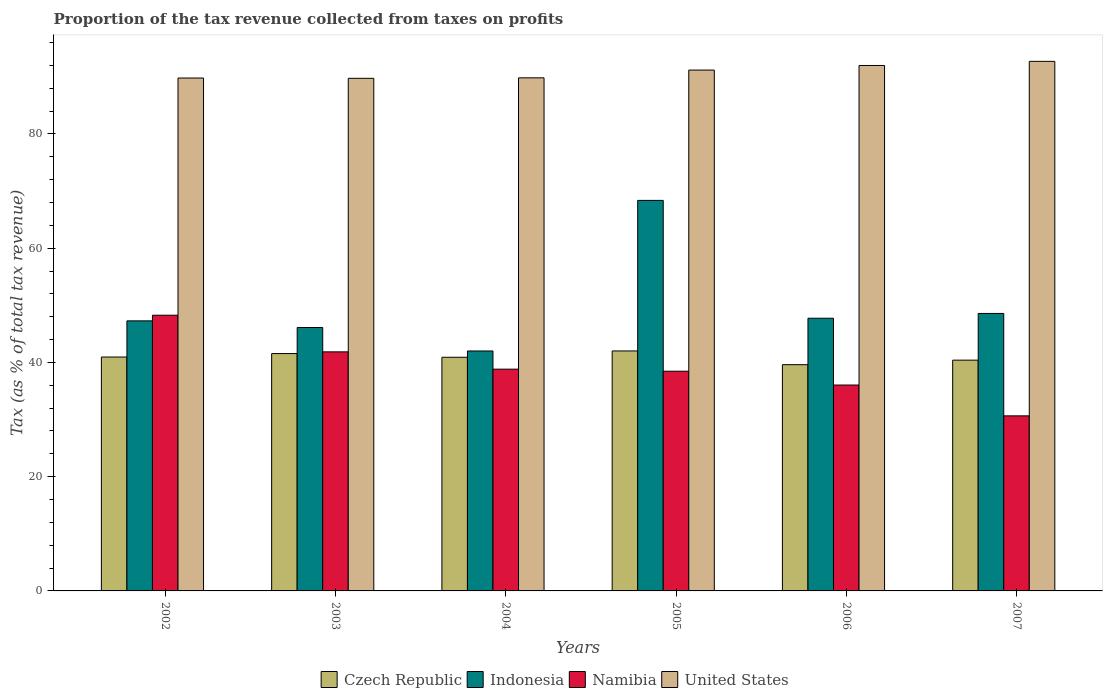How many different coloured bars are there?
Provide a succinct answer. 4. How many groups of bars are there?
Provide a short and direct response. 6. Are the number of bars per tick equal to the number of legend labels?
Your answer should be compact. Yes. Are the number of bars on each tick of the X-axis equal?
Your response must be concise. Yes. How many bars are there on the 2nd tick from the left?
Provide a short and direct response. 4. What is the label of the 2nd group of bars from the left?
Provide a succinct answer. 2003. In how many cases, is the number of bars for a given year not equal to the number of legend labels?
Give a very brief answer. 0. What is the proportion of the tax revenue collected in Indonesia in 2005?
Your answer should be compact. 68.37. Across all years, what is the maximum proportion of the tax revenue collected in Indonesia?
Provide a short and direct response. 68.37. Across all years, what is the minimum proportion of the tax revenue collected in Czech Republic?
Offer a terse response. 39.61. In which year was the proportion of the tax revenue collected in Czech Republic maximum?
Your response must be concise. 2005. What is the total proportion of the tax revenue collected in United States in the graph?
Make the answer very short. 545.26. What is the difference between the proportion of the tax revenue collected in Namibia in 2003 and that in 2005?
Give a very brief answer. 3.39. What is the difference between the proportion of the tax revenue collected in United States in 2006 and the proportion of the tax revenue collected in Namibia in 2004?
Keep it short and to the point. 53.17. What is the average proportion of the tax revenue collected in Namibia per year?
Your answer should be compact. 39.02. In the year 2005, what is the difference between the proportion of the tax revenue collected in Czech Republic and proportion of the tax revenue collected in United States?
Give a very brief answer. -49.17. What is the ratio of the proportion of the tax revenue collected in United States in 2003 to that in 2005?
Provide a short and direct response. 0.98. Is the proportion of the tax revenue collected in Indonesia in 2003 less than that in 2007?
Provide a succinct answer. Yes. What is the difference between the highest and the second highest proportion of the tax revenue collected in United States?
Offer a terse response. 0.72. What is the difference between the highest and the lowest proportion of the tax revenue collected in Czech Republic?
Provide a short and direct response. 2.4. In how many years, is the proportion of the tax revenue collected in Czech Republic greater than the average proportion of the tax revenue collected in Czech Republic taken over all years?
Your response must be concise. 3. Is the sum of the proportion of the tax revenue collected in Czech Republic in 2003 and 2007 greater than the maximum proportion of the tax revenue collected in Namibia across all years?
Your response must be concise. Yes. What does the 1st bar from the left in 2007 represents?
Keep it short and to the point. Czech Republic. What does the 2nd bar from the right in 2006 represents?
Make the answer very short. Namibia. How many bars are there?
Offer a very short reply. 24. What is the difference between two consecutive major ticks on the Y-axis?
Make the answer very short. 20. Are the values on the major ticks of Y-axis written in scientific E-notation?
Make the answer very short. No. How are the legend labels stacked?
Provide a short and direct response. Horizontal. What is the title of the graph?
Ensure brevity in your answer.  Proportion of the tax revenue collected from taxes on profits. What is the label or title of the Y-axis?
Your response must be concise. Tax (as % of total tax revenue). What is the Tax (as % of total tax revenue) of Czech Republic in 2002?
Offer a very short reply. 40.95. What is the Tax (as % of total tax revenue) in Indonesia in 2002?
Give a very brief answer. 47.28. What is the Tax (as % of total tax revenue) of Namibia in 2002?
Offer a very short reply. 48.27. What is the Tax (as % of total tax revenue) in United States in 2002?
Your answer should be very brief. 89.8. What is the Tax (as % of total tax revenue) in Czech Republic in 2003?
Your response must be concise. 41.55. What is the Tax (as % of total tax revenue) of Indonesia in 2003?
Your answer should be very brief. 46.12. What is the Tax (as % of total tax revenue) in Namibia in 2003?
Your answer should be compact. 41.85. What is the Tax (as % of total tax revenue) of United States in 2003?
Your answer should be compact. 89.74. What is the Tax (as % of total tax revenue) of Czech Republic in 2004?
Keep it short and to the point. 40.91. What is the Tax (as % of total tax revenue) in Indonesia in 2004?
Your answer should be compact. 42.01. What is the Tax (as % of total tax revenue) in Namibia in 2004?
Your answer should be compact. 38.82. What is the Tax (as % of total tax revenue) of United States in 2004?
Give a very brief answer. 89.83. What is the Tax (as % of total tax revenue) in Czech Republic in 2005?
Your response must be concise. 42.01. What is the Tax (as % of total tax revenue) in Indonesia in 2005?
Make the answer very short. 68.37. What is the Tax (as % of total tax revenue) of Namibia in 2005?
Make the answer very short. 38.47. What is the Tax (as % of total tax revenue) in United States in 2005?
Provide a short and direct response. 91.19. What is the Tax (as % of total tax revenue) in Czech Republic in 2006?
Provide a short and direct response. 39.61. What is the Tax (as % of total tax revenue) in Indonesia in 2006?
Your response must be concise. 47.74. What is the Tax (as % of total tax revenue) in Namibia in 2006?
Your answer should be very brief. 36.05. What is the Tax (as % of total tax revenue) in United States in 2006?
Ensure brevity in your answer.  91.99. What is the Tax (as % of total tax revenue) in Czech Republic in 2007?
Offer a terse response. 40.4. What is the Tax (as % of total tax revenue) in Indonesia in 2007?
Keep it short and to the point. 48.58. What is the Tax (as % of total tax revenue) in Namibia in 2007?
Your response must be concise. 30.65. What is the Tax (as % of total tax revenue) of United States in 2007?
Your answer should be very brief. 92.71. Across all years, what is the maximum Tax (as % of total tax revenue) in Czech Republic?
Your response must be concise. 42.01. Across all years, what is the maximum Tax (as % of total tax revenue) in Indonesia?
Your answer should be very brief. 68.37. Across all years, what is the maximum Tax (as % of total tax revenue) of Namibia?
Provide a short and direct response. 48.27. Across all years, what is the maximum Tax (as % of total tax revenue) in United States?
Offer a terse response. 92.71. Across all years, what is the minimum Tax (as % of total tax revenue) in Czech Republic?
Your answer should be very brief. 39.61. Across all years, what is the minimum Tax (as % of total tax revenue) in Indonesia?
Provide a succinct answer. 42.01. Across all years, what is the minimum Tax (as % of total tax revenue) in Namibia?
Give a very brief answer. 30.65. Across all years, what is the minimum Tax (as % of total tax revenue) of United States?
Ensure brevity in your answer.  89.74. What is the total Tax (as % of total tax revenue) in Czech Republic in the graph?
Provide a short and direct response. 245.44. What is the total Tax (as % of total tax revenue) in Indonesia in the graph?
Your answer should be compact. 300.09. What is the total Tax (as % of total tax revenue) of Namibia in the graph?
Make the answer very short. 234.11. What is the total Tax (as % of total tax revenue) in United States in the graph?
Provide a succinct answer. 545.26. What is the difference between the Tax (as % of total tax revenue) in Czech Republic in 2002 and that in 2003?
Offer a terse response. -0.6. What is the difference between the Tax (as % of total tax revenue) of Indonesia in 2002 and that in 2003?
Your response must be concise. 1.16. What is the difference between the Tax (as % of total tax revenue) in Namibia in 2002 and that in 2003?
Ensure brevity in your answer.  6.42. What is the difference between the Tax (as % of total tax revenue) in United States in 2002 and that in 2003?
Keep it short and to the point. 0.05. What is the difference between the Tax (as % of total tax revenue) of Czech Republic in 2002 and that in 2004?
Your response must be concise. 0.04. What is the difference between the Tax (as % of total tax revenue) of Indonesia in 2002 and that in 2004?
Give a very brief answer. 5.27. What is the difference between the Tax (as % of total tax revenue) of Namibia in 2002 and that in 2004?
Provide a succinct answer. 9.45. What is the difference between the Tax (as % of total tax revenue) of United States in 2002 and that in 2004?
Offer a terse response. -0.03. What is the difference between the Tax (as % of total tax revenue) of Czech Republic in 2002 and that in 2005?
Offer a very short reply. -1.06. What is the difference between the Tax (as % of total tax revenue) of Indonesia in 2002 and that in 2005?
Make the answer very short. -21.09. What is the difference between the Tax (as % of total tax revenue) of Namibia in 2002 and that in 2005?
Offer a very short reply. 9.8. What is the difference between the Tax (as % of total tax revenue) in United States in 2002 and that in 2005?
Make the answer very short. -1.39. What is the difference between the Tax (as % of total tax revenue) in Czech Republic in 2002 and that in 2006?
Offer a terse response. 1.34. What is the difference between the Tax (as % of total tax revenue) of Indonesia in 2002 and that in 2006?
Provide a succinct answer. -0.46. What is the difference between the Tax (as % of total tax revenue) in Namibia in 2002 and that in 2006?
Make the answer very short. 12.22. What is the difference between the Tax (as % of total tax revenue) in United States in 2002 and that in 2006?
Keep it short and to the point. -2.2. What is the difference between the Tax (as % of total tax revenue) of Czech Republic in 2002 and that in 2007?
Ensure brevity in your answer.  0.55. What is the difference between the Tax (as % of total tax revenue) of Indonesia in 2002 and that in 2007?
Give a very brief answer. -1.3. What is the difference between the Tax (as % of total tax revenue) in Namibia in 2002 and that in 2007?
Keep it short and to the point. 17.62. What is the difference between the Tax (as % of total tax revenue) in United States in 2002 and that in 2007?
Your response must be concise. -2.92. What is the difference between the Tax (as % of total tax revenue) of Czech Republic in 2003 and that in 2004?
Offer a terse response. 0.65. What is the difference between the Tax (as % of total tax revenue) of Indonesia in 2003 and that in 2004?
Give a very brief answer. 4.11. What is the difference between the Tax (as % of total tax revenue) of Namibia in 2003 and that in 2004?
Keep it short and to the point. 3.03. What is the difference between the Tax (as % of total tax revenue) in United States in 2003 and that in 2004?
Make the answer very short. -0.08. What is the difference between the Tax (as % of total tax revenue) in Czech Republic in 2003 and that in 2005?
Your answer should be very brief. -0.46. What is the difference between the Tax (as % of total tax revenue) of Indonesia in 2003 and that in 2005?
Your answer should be very brief. -22.25. What is the difference between the Tax (as % of total tax revenue) in Namibia in 2003 and that in 2005?
Offer a very short reply. 3.39. What is the difference between the Tax (as % of total tax revenue) in United States in 2003 and that in 2005?
Ensure brevity in your answer.  -1.44. What is the difference between the Tax (as % of total tax revenue) of Czech Republic in 2003 and that in 2006?
Give a very brief answer. 1.95. What is the difference between the Tax (as % of total tax revenue) of Indonesia in 2003 and that in 2006?
Your response must be concise. -1.62. What is the difference between the Tax (as % of total tax revenue) of Namibia in 2003 and that in 2006?
Your answer should be compact. 5.81. What is the difference between the Tax (as % of total tax revenue) of United States in 2003 and that in 2006?
Offer a terse response. -2.25. What is the difference between the Tax (as % of total tax revenue) in Czech Republic in 2003 and that in 2007?
Ensure brevity in your answer.  1.15. What is the difference between the Tax (as % of total tax revenue) in Indonesia in 2003 and that in 2007?
Ensure brevity in your answer.  -2.46. What is the difference between the Tax (as % of total tax revenue) of Namibia in 2003 and that in 2007?
Your answer should be very brief. 11.2. What is the difference between the Tax (as % of total tax revenue) of United States in 2003 and that in 2007?
Offer a terse response. -2.97. What is the difference between the Tax (as % of total tax revenue) of Czech Republic in 2004 and that in 2005?
Provide a succinct answer. -1.11. What is the difference between the Tax (as % of total tax revenue) of Indonesia in 2004 and that in 2005?
Provide a succinct answer. -26.36. What is the difference between the Tax (as % of total tax revenue) in Namibia in 2004 and that in 2005?
Your answer should be compact. 0.36. What is the difference between the Tax (as % of total tax revenue) in United States in 2004 and that in 2005?
Provide a succinct answer. -1.36. What is the difference between the Tax (as % of total tax revenue) in Czech Republic in 2004 and that in 2006?
Offer a very short reply. 1.3. What is the difference between the Tax (as % of total tax revenue) of Indonesia in 2004 and that in 2006?
Keep it short and to the point. -5.73. What is the difference between the Tax (as % of total tax revenue) in Namibia in 2004 and that in 2006?
Ensure brevity in your answer.  2.78. What is the difference between the Tax (as % of total tax revenue) of United States in 2004 and that in 2006?
Ensure brevity in your answer.  -2.17. What is the difference between the Tax (as % of total tax revenue) in Czech Republic in 2004 and that in 2007?
Offer a terse response. 0.5. What is the difference between the Tax (as % of total tax revenue) in Indonesia in 2004 and that in 2007?
Give a very brief answer. -6.57. What is the difference between the Tax (as % of total tax revenue) of Namibia in 2004 and that in 2007?
Ensure brevity in your answer.  8.17. What is the difference between the Tax (as % of total tax revenue) of United States in 2004 and that in 2007?
Keep it short and to the point. -2.89. What is the difference between the Tax (as % of total tax revenue) of Czech Republic in 2005 and that in 2006?
Provide a short and direct response. 2.4. What is the difference between the Tax (as % of total tax revenue) in Indonesia in 2005 and that in 2006?
Ensure brevity in your answer.  20.63. What is the difference between the Tax (as % of total tax revenue) of Namibia in 2005 and that in 2006?
Offer a terse response. 2.42. What is the difference between the Tax (as % of total tax revenue) in United States in 2005 and that in 2006?
Make the answer very short. -0.81. What is the difference between the Tax (as % of total tax revenue) in Czech Republic in 2005 and that in 2007?
Your response must be concise. 1.61. What is the difference between the Tax (as % of total tax revenue) of Indonesia in 2005 and that in 2007?
Provide a succinct answer. 19.79. What is the difference between the Tax (as % of total tax revenue) in Namibia in 2005 and that in 2007?
Provide a succinct answer. 7.82. What is the difference between the Tax (as % of total tax revenue) of United States in 2005 and that in 2007?
Keep it short and to the point. -1.53. What is the difference between the Tax (as % of total tax revenue) in Czech Republic in 2006 and that in 2007?
Provide a short and direct response. -0.79. What is the difference between the Tax (as % of total tax revenue) of Indonesia in 2006 and that in 2007?
Make the answer very short. -0.84. What is the difference between the Tax (as % of total tax revenue) in Namibia in 2006 and that in 2007?
Give a very brief answer. 5.4. What is the difference between the Tax (as % of total tax revenue) of United States in 2006 and that in 2007?
Provide a short and direct response. -0.72. What is the difference between the Tax (as % of total tax revenue) in Czech Republic in 2002 and the Tax (as % of total tax revenue) in Indonesia in 2003?
Your answer should be very brief. -5.17. What is the difference between the Tax (as % of total tax revenue) of Czech Republic in 2002 and the Tax (as % of total tax revenue) of Namibia in 2003?
Provide a short and direct response. -0.9. What is the difference between the Tax (as % of total tax revenue) in Czech Republic in 2002 and the Tax (as % of total tax revenue) in United States in 2003?
Provide a succinct answer. -48.79. What is the difference between the Tax (as % of total tax revenue) of Indonesia in 2002 and the Tax (as % of total tax revenue) of Namibia in 2003?
Give a very brief answer. 5.43. What is the difference between the Tax (as % of total tax revenue) in Indonesia in 2002 and the Tax (as % of total tax revenue) in United States in 2003?
Keep it short and to the point. -42.46. What is the difference between the Tax (as % of total tax revenue) in Namibia in 2002 and the Tax (as % of total tax revenue) in United States in 2003?
Offer a terse response. -41.47. What is the difference between the Tax (as % of total tax revenue) in Czech Republic in 2002 and the Tax (as % of total tax revenue) in Indonesia in 2004?
Provide a succinct answer. -1.06. What is the difference between the Tax (as % of total tax revenue) in Czech Republic in 2002 and the Tax (as % of total tax revenue) in Namibia in 2004?
Offer a terse response. 2.13. What is the difference between the Tax (as % of total tax revenue) of Czech Republic in 2002 and the Tax (as % of total tax revenue) of United States in 2004?
Give a very brief answer. -48.88. What is the difference between the Tax (as % of total tax revenue) of Indonesia in 2002 and the Tax (as % of total tax revenue) of Namibia in 2004?
Offer a terse response. 8.46. What is the difference between the Tax (as % of total tax revenue) of Indonesia in 2002 and the Tax (as % of total tax revenue) of United States in 2004?
Provide a succinct answer. -42.55. What is the difference between the Tax (as % of total tax revenue) in Namibia in 2002 and the Tax (as % of total tax revenue) in United States in 2004?
Your response must be concise. -41.56. What is the difference between the Tax (as % of total tax revenue) in Czech Republic in 2002 and the Tax (as % of total tax revenue) in Indonesia in 2005?
Provide a short and direct response. -27.42. What is the difference between the Tax (as % of total tax revenue) in Czech Republic in 2002 and the Tax (as % of total tax revenue) in Namibia in 2005?
Your answer should be very brief. 2.48. What is the difference between the Tax (as % of total tax revenue) in Czech Republic in 2002 and the Tax (as % of total tax revenue) in United States in 2005?
Keep it short and to the point. -50.24. What is the difference between the Tax (as % of total tax revenue) in Indonesia in 2002 and the Tax (as % of total tax revenue) in Namibia in 2005?
Your answer should be compact. 8.81. What is the difference between the Tax (as % of total tax revenue) of Indonesia in 2002 and the Tax (as % of total tax revenue) of United States in 2005?
Your answer should be very brief. -43.91. What is the difference between the Tax (as % of total tax revenue) in Namibia in 2002 and the Tax (as % of total tax revenue) in United States in 2005?
Give a very brief answer. -42.92. What is the difference between the Tax (as % of total tax revenue) in Czech Republic in 2002 and the Tax (as % of total tax revenue) in Indonesia in 2006?
Give a very brief answer. -6.79. What is the difference between the Tax (as % of total tax revenue) of Czech Republic in 2002 and the Tax (as % of total tax revenue) of Namibia in 2006?
Ensure brevity in your answer.  4.9. What is the difference between the Tax (as % of total tax revenue) in Czech Republic in 2002 and the Tax (as % of total tax revenue) in United States in 2006?
Provide a short and direct response. -51.04. What is the difference between the Tax (as % of total tax revenue) in Indonesia in 2002 and the Tax (as % of total tax revenue) in Namibia in 2006?
Keep it short and to the point. 11.23. What is the difference between the Tax (as % of total tax revenue) of Indonesia in 2002 and the Tax (as % of total tax revenue) of United States in 2006?
Make the answer very short. -44.71. What is the difference between the Tax (as % of total tax revenue) in Namibia in 2002 and the Tax (as % of total tax revenue) in United States in 2006?
Provide a succinct answer. -43.72. What is the difference between the Tax (as % of total tax revenue) in Czech Republic in 2002 and the Tax (as % of total tax revenue) in Indonesia in 2007?
Your response must be concise. -7.63. What is the difference between the Tax (as % of total tax revenue) of Czech Republic in 2002 and the Tax (as % of total tax revenue) of Namibia in 2007?
Offer a very short reply. 10.3. What is the difference between the Tax (as % of total tax revenue) in Czech Republic in 2002 and the Tax (as % of total tax revenue) in United States in 2007?
Keep it short and to the point. -51.76. What is the difference between the Tax (as % of total tax revenue) of Indonesia in 2002 and the Tax (as % of total tax revenue) of Namibia in 2007?
Your answer should be compact. 16.63. What is the difference between the Tax (as % of total tax revenue) of Indonesia in 2002 and the Tax (as % of total tax revenue) of United States in 2007?
Ensure brevity in your answer.  -45.43. What is the difference between the Tax (as % of total tax revenue) of Namibia in 2002 and the Tax (as % of total tax revenue) of United States in 2007?
Ensure brevity in your answer.  -44.45. What is the difference between the Tax (as % of total tax revenue) of Czech Republic in 2003 and the Tax (as % of total tax revenue) of Indonesia in 2004?
Offer a very short reply. -0.45. What is the difference between the Tax (as % of total tax revenue) in Czech Republic in 2003 and the Tax (as % of total tax revenue) in Namibia in 2004?
Provide a short and direct response. 2.73. What is the difference between the Tax (as % of total tax revenue) in Czech Republic in 2003 and the Tax (as % of total tax revenue) in United States in 2004?
Provide a short and direct response. -48.27. What is the difference between the Tax (as % of total tax revenue) in Indonesia in 2003 and the Tax (as % of total tax revenue) in Namibia in 2004?
Your answer should be very brief. 7.29. What is the difference between the Tax (as % of total tax revenue) of Indonesia in 2003 and the Tax (as % of total tax revenue) of United States in 2004?
Provide a succinct answer. -43.71. What is the difference between the Tax (as % of total tax revenue) in Namibia in 2003 and the Tax (as % of total tax revenue) in United States in 2004?
Offer a very short reply. -47.97. What is the difference between the Tax (as % of total tax revenue) in Czech Republic in 2003 and the Tax (as % of total tax revenue) in Indonesia in 2005?
Keep it short and to the point. -26.82. What is the difference between the Tax (as % of total tax revenue) in Czech Republic in 2003 and the Tax (as % of total tax revenue) in Namibia in 2005?
Your answer should be compact. 3.09. What is the difference between the Tax (as % of total tax revenue) of Czech Republic in 2003 and the Tax (as % of total tax revenue) of United States in 2005?
Your answer should be compact. -49.63. What is the difference between the Tax (as % of total tax revenue) of Indonesia in 2003 and the Tax (as % of total tax revenue) of Namibia in 2005?
Ensure brevity in your answer.  7.65. What is the difference between the Tax (as % of total tax revenue) of Indonesia in 2003 and the Tax (as % of total tax revenue) of United States in 2005?
Provide a short and direct response. -45.07. What is the difference between the Tax (as % of total tax revenue) of Namibia in 2003 and the Tax (as % of total tax revenue) of United States in 2005?
Give a very brief answer. -49.33. What is the difference between the Tax (as % of total tax revenue) of Czech Republic in 2003 and the Tax (as % of total tax revenue) of Indonesia in 2006?
Give a very brief answer. -6.18. What is the difference between the Tax (as % of total tax revenue) of Czech Republic in 2003 and the Tax (as % of total tax revenue) of Namibia in 2006?
Give a very brief answer. 5.51. What is the difference between the Tax (as % of total tax revenue) in Czech Republic in 2003 and the Tax (as % of total tax revenue) in United States in 2006?
Make the answer very short. -50.44. What is the difference between the Tax (as % of total tax revenue) of Indonesia in 2003 and the Tax (as % of total tax revenue) of Namibia in 2006?
Keep it short and to the point. 10.07. What is the difference between the Tax (as % of total tax revenue) of Indonesia in 2003 and the Tax (as % of total tax revenue) of United States in 2006?
Give a very brief answer. -45.88. What is the difference between the Tax (as % of total tax revenue) in Namibia in 2003 and the Tax (as % of total tax revenue) in United States in 2006?
Your answer should be very brief. -50.14. What is the difference between the Tax (as % of total tax revenue) of Czech Republic in 2003 and the Tax (as % of total tax revenue) of Indonesia in 2007?
Your answer should be very brief. -7.02. What is the difference between the Tax (as % of total tax revenue) in Czech Republic in 2003 and the Tax (as % of total tax revenue) in Namibia in 2007?
Ensure brevity in your answer.  10.9. What is the difference between the Tax (as % of total tax revenue) in Czech Republic in 2003 and the Tax (as % of total tax revenue) in United States in 2007?
Your response must be concise. -51.16. What is the difference between the Tax (as % of total tax revenue) in Indonesia in 2003 and the Tax (as % of total tax revenue) in Namibia in 2007?
Your answer should be very brief. 15.47. What is the difference between the Tax (as % of total tax revenue) of Indonesia in 2003 and the Tax (as % of total tax revenue) of United States in 2007?
Offer a terse response. -46.6. What is the difference between the Tax (as % of total tax revenue) of Namibia in 2003 and the Tax (as % of total tax revenue) of United States in 2007?
Make the answer very short. -50.86. What is the difference between the Tax (as % of total tax revenue) in Czech Republic in 2004 and the Tax (as % of total tax revenue) in Indonesia in 2005?
Offer a terse response. -27.46. What is the difference between the Tax (as % of total tax revenue) of Czech Republic in 2004 and the Tax (as % of total tax revenue) of Namibia in 2005?
Keep it short and to the point. 2.44. What is the difference between the Tax (as % of total tax revenue) in Czech Republic in 2004 and the Tax (as % of total tax revenue) in United States in 2005?
Offer a terse response. -50.28. What is the difference between the Tax (as % of total tax revenue) of Indonesia in 2004 and the Tax (as % of total tax revenue) of Namibia in 2005?
Offer a terse response. 3.54. What is the difference between the Tax (as % of total tax revenue) in Indonesia in 2004 and the Tax (as % of total tax revenue) in United States in 2005?
Keep it short and to the point. -49.18. What is the difference between the Tax (as % of total tax revenue) in Namibia in 2004 and the Tax (as % of total tax revenue) in United States in 2005?
Provide a short and direct response. -52.36. What is the difference between the Tax (as % of total tax revenue) of Czech Republic in 2004 and the Tax (as % of total tax revenue) of Indonesia in 2006?
Offer a terse response. -6.83. What is the difference between the Tax (as % of total tax revenue) of Czech Republic in 2004 and the Tax (as % of total tax revenue) of Namibia in 2006?
Your answer should be compact. 4.86. What is the difference between the Tax (as % of total tax revenue) in Czech Republic in 2004 and the Tax (as % of total tax revenue) in United States in 2006?
Your response must be concise. -51.09. What is the difference between the Tax (as % of total tax revenue) in Indonesia in 2004 and the Tax (as % of total tax revenue) in Namibia in 2006?
Your answer should be compact. 5.96. What is the difference between the Tax (as % of total tax revenue) in Indonesia in 2004 and the Tax (as % of total tax revenue) in United States in 2006?
Provide a short and direct response. -49.99. What is the difference between the Tax (as % of total tax revenue) of Namibia in 2004 and the Tax (as % of total tax revenue) of United States in 2006?
Offer a very short reply. -53.17. What is the difference between the Tax (as % of total tax revenue) of Czech Republic in 2004 and the Tax (as % of total tax revenue) of Indonesia in 2007?
Your answer should be compact. -7.67. What is the difference between the Tax (as % of total tax revenue) in Czech Republic in 2004 and the Tax (as % of total tax revenue) in Namibia in 2007?
Your response must be concise. 10.26. What is the difference between the Tax (as % of total tax revenue) of Czech Republic in 2004 and the Tax (as % of total tax revenue) of United States in 2007?
Your answer should be compact. -51.81. What is the difference between the Tax (as % of total tax revenue) of Indonesia in 2004 and the Tax (as % of total tax revenue) of Namibia in 2007?
Ensure brevity in your answer.  11.36. What is the difference between the Tax (as % of total tax revenue) in Indonesia in 2004 and the Tax (as % of total tax revenue) in United States in 2007?
Your answer should be compact. -50.71. What is the difference between the Tax (as % of total tax revenue) of Namibia in 2004 and the Tax (as % of total tax revenue) of United States in 2007?
Keep it short and to the point. -53.89. What is the difference between the Tax (as % of total tax revenue) in Czech Republic in 2005 and the Tax (as % of total tax revenue) in Indonesia in 2006?
Your answer should be very brief. -5.73. What is the difference between the Tax (as % of total tax revenue) in Czech Republic in 2005 and the Tax (as % of total tax revenue) in Namibia in 2006?
Offer a terse response. 5.97. What is the difference between the Tax (as % of total tax revenue) of Czech Republic in 2005 and the Tax (as % of total tax revenue) of United States in 2006?
Provide a succinct answer. -49.98. What is the difference between the Tax (as % of total tax revenue) in Indonesia in 2005 and the Tax (as % of total tax revenue) in Namibia in 2006?
Your answer should be compact. 32.32. What is the difference between the Tax (as % of total tax revenue) in Indonesia in 2005 and the Tax (as % of total tax revenue) in United States in 2006?
Provide a succinct answer. -23.62. What is the difference between the Tax (as % of total tax revenue) in Namibia in 2005 and the Tax (as % of total tax revenue) in United States in 2006?
Your answer should be very brief. -53.53. What is the difference between the Tax (as % of total tax revenue) in Czech Republic in 2005 and the Tax (as % of total tax revenue) in Indonesia in 2007?
Offer a very short reply. -6.57. What is the difference between the Tax (as % of total tax revenue) of Czech Republic in 2005 and the Tax (as % of total tax revenue) of Namibia in 2007?
Provide a succinct answer. 11.36. What is the difference between the Tax (as % of total tax revenue) of Czech Republic in 2005 and the Tax (as % of total tax revenue) of United States in 2007?
Offer a terse response. -50.7. What is the difference between the Tax (as % of total tax revenue) in Indonesia in 2005 and the Tax (as % of total tax revenue) in Namibia in 2007?
Give a very brief answer. 37.72. What is the difference between the Tax (as % of total tax revenue) of Indonesia in 2005 and the Tax (as % of total tax revenue) of United States in 2007?
Provide a succinct answer. -24.34. What is the difference between the Tax (as % of total tax revenue) of Namibia in 2005 and the Tax (as % of total tax revenue) of United States in 2007?
Provide a short and direct response. -54.25. What is the difference between the Tax (as % of total tax revenue) in Czech Republic in 2006 and the Tax (as % of total tax revenue) in Indonesia in 2007?
Make the answer very short. -8.97. What is the difference between the Tax (as % of total tax revenue) in Czech Republic in 2006 and the Tax (as % of total tax revenue) in Namibia in 2007?
Provide a succinct answer. 8.96. What is the difference between the Tax (as % of total tax revenue) of Czech Republic in 2006 and the Tax (as % of total tax revenue) of United States in 2007?
Offer a very short reply. -53.11. What is the difference between the Tax (as % of total tax revenue) in Indonesia in 2006 and the Tax (as % of total tax revenue) in Namibia in 2007?
Offer a terse response. 17.09. What is the difference between the Tax (as % of total tax revenue) in Indonesia in 2006 and the Tax (as % of total tax revenue) in United States in 2007?
Keep it short and to the point. -44.98. What is the difference between the Tax (as % of total tax revenue) of Namibia in 2006 and the Tax (as % of total tax revenue) of United States in 2007?
Your answer should be compact. -56.67. What is the average Tax (as % of total tax revenue) in Czech Republic per year?
Your response must be concise. 40.91. What is the average Tax (as % of total tax revenue) of Indonesia per year?
Provide a succinct answer. 50.02. What is the average Tax (as % of total tax revenue) in Namibia per year?
Your response must be concise. 39.02. What is the average Tax (as % of total tax revenue) in United States per year?
Make the answer very short. 90.88. In the year 2002, what is the difference between the Tax (as % of total tax revenue) of Czech Republic and Tax (as % of total tax revenue) of Indonesia?
Make the answer very short. -6.33. In the year 2002, what is the difference between the Tax (as % of total tax revenue) of Czech Republic and Tax (as % of total tax revenue) of Namibia?
Give a very brief answer. -7.32. In the year 2002, what is the difference between the Tax (as % of total tax revenue) in Czech Republic and Tax (as % of total tax revenue) in United States?
Ensure brevity in your answer.  -48.85. In the year 2002, what is the difference between the Tax (as % of total tax revenue) in Indonesia and Tax (as % of total tax revenue) in Namibia?
Your response must be concise. -0.99. In the year 2002, what is the difference between the Tax (as % of total tax revenue) of Indonesia and Tax (as % of total tax revenue) of United States?
Provide a succinct answer. -42.52. In the year 2002, what is the difference between the Tax (as % of total tax revenue) in Namibia and Tax (as % of total tax revenue) in United States?
Provide a short and direct response. -41.53. In the year 2003, what is the difference between the Tax (as % of total tax revenue) of Czech Republic and Tax (as % of total tax revenue) of Indonesia?
Provide a succinct answer. -4.56. In the year 2003, what is the difference between the Tax (as % of total tax revenue) in Czech Republic and Tax (as % of total tax revenue) in Namibia?
Keep it short and to the point. -0.3. In the year 2003, what is the difference between the Tax (as % of total tax revenue) in Czech Republic and Tax (as % of total tax revenue) in United States?
Give a very brief answer. -48.19. In the year 2003, what is the difference between the Tax (as % of total tax revenue) in Indonesia and Tax (as % of total tax revenue) in Namibia?
Your answer should be very brief. 4.26. In the year 2003, what is the difference between the Tax (as % of total tax revenue) of Indonesia and Tax (as % of total tax revenue) of United States?
Your response must be concise. -43.63. In the year 2003, what is the difference between the Tax (as % of total tax revenue) in Namibia and Tax (as % of total tax revenue) in United States?
Offer a terse response. -47.89. In the year 2004, what is the difference between the Tax (as % of total tax revenue) of Czech Republic and Tax (as % of total tax revenue) of Indonesia?
Provide a succinct answer. -1.1. In the year 2004, what is the difference between the Tax (as % of total tax revenue) in Czech Republic and Tax (as % of total tax revenue) in Namibia?
Offer a very short reply. 2.08. In the year 2004, what is the difference between the Tax (as % of total tax revenue) in Czech Republic and Tax (as % of total tax revenue) in United States?
Ensure brevity in your answer.  -48.92. In the year 2004, what is the difference between the Tax (as % of total tax revenue) in Indonesia and Tax (as % of total tax revenue) in Namibia?
Your answer should be very brief. 3.18. In the year 2004, what is the difference between the Tax (as % of total tax revenue) of Indonesia and Tax (as % of total tax revenue) of United States?
Give a very brief answer. -47.82. In the year 2004, what is the difference between the Tax (as % of total tax revenue) in Namibia and Tax (as % of total tax revenue) in United States?
Offer a very short reply. -51. In the year 2005, what is the difference between the Tax (as % of total tax revenue) in Czech Republic and Tax (as % of total tax revenue) in Indonesia?
Provide a succinct answer. -26.36. In the year 2005, what is the difference between the Tax (as % of total tax revenue) of Czech Republic and Tax (as % of total tax revenue) of Namibia?
Provide a short and direct response. 3.55. In the year 2005, what is the difference between the Tax (as % of total tax revenue) of Czech Republic and Tax (as % of total tax revenue) of United States?
Your answer should be compact. -49.17. In the year 2005, what is the difference between the Tax (as % of total tax revenue) in Indonesia and Tax (as % of total tax revenue) in Namibia?
Your answer should be very brief. 29.9. In the year 2005, what is the difference between the Tax (as % of total tax revenue) of Indonesia and Tax (as % of total tax revenue) of United States?
Keep it short and to the point. -22.82. In the year 2005, what is the difference between the Tax (as % of total tax revenue) in Namibia and Tax (as % of total tax revenue) in United States?
Your response must be concise. -52.72. In the year 2006, what is the difference between the Tax (as % of total tax revenue) of Czech Republic and Tax (as % of total tax revenue) of Indonesia?
Your answer should be compact. -8.13. In the year 2006, what is the difference between the Tax (as % of total tax revenue) of Czech Republic and Tax (as % of total tax revenue) of Namibia?
Your answer should be very brief. 3.56. In the year 2006, what is the difference between the Tax (as % of total tax revenue) of Czech Republic and Tax (as % of total tax revenue) of United States?
Keep it short and to the point. -52.38. In the year 2006, what is the difference between the Tax (as % of total tax revenue) in Indonesia and Tax (as % of total tax revenue) in Namibia?
Ensure brevity in your answer.  11.69. In the year 2006, what is the difference between the Tax (as % of total tax revenue) in Indonesia and Tax (as % of total tax revenue) in United States?
Your response must be concise. -44.26. In the year 2006, what is the difference between the Tax (as % of total tax revenue) of Namibia and Tax (as % of total tax revenue) of United States?
Your answer should be compact. -55.95. In the year 2007, what is the difference between the Tax (as % of total tax revenue) of Czech Republic and Tax (as % of total tax revenue) of Indonesia?
Keep it short and to the point. -8.17. In the year 2007, what is the difference between the Tax (as % of total tax revenue) in Czech Republic and Tax (as % of total tax revenue) in Namibia?
Your answer should be compact. 9.75. In the year 2007, what is the difference between the Tax (as % of total tax revenue) in Czech Republic and Tax (as % of total tax revenue) in United States?
Offer a terse response. -52.31. In the year 2007, what is the difference between the Tax (as % of total tax revenue) in Indonesia and Tax (as % of total tax revenue) in Namibia?
Provide a succinct answer. 17.93. In the year 2007, what is the difference between the Tax (as % of total tax revenue) of Indonesia and Tax (as % of total tax revenue) of United States?
Provide a succinct answer. -44.14. In the year 2007, what is the difference between the Tax (as % of total tax revenue) of Namibia and Tax (as % of total tax revenue) of United States?
Provide a succinct answer. -62.07. What is the ratio of the Tax (as % of total tax revenue) of Czech Republic in 2002 to that in 2003?
Provide a succinct answer. 0.99. What is the ratio of the Tax (as % of total tax revenue) in Indonesia in 2002 to that in 2003?
Your answer should be compact. 1.03. What is the ratio of the Tax (as % of total tax revenue) in Namibia in 2002 to that in 2003?
Provide a succinct answer. 1.15. What is the ratio of the Tax (as % of total tax revenue) of United States in 2002 to that in 2003?
Your response must be concise. 1. What is the ratio of the Tax (as % of total tax revenue) in Indonesia in 2002 to that in 2004?
Provide a succinct answer. 1.13. What is the ratio of the Tax (as % of total tax revenue) of Namibia in 2002 to that in 2004?
Provide a short and direct response. 1.24. What is the ratio of the Tax (as % of total tax revenue) in Czech Republic in 2002 to that in 2005?
Your answer should be compact. 0.97. What is the ratio of the Tax (as % of total tax revenue) of Indonesia in 2002 to that in 2005?
Offer a very short reply. 0.69. What is the ratio of the Tax (as % of total tax revenue) in Namibia in 2002 to that in 2005?
Make the answer very short. 1.25. What is the ratio of the Tax (as % of total tax revenue) in United States in 2002 to that in 2005?
Give a very brief answer. 0.98. What is the ratio of the Tax (as % of total tax revenue) in Czech Republic in 2002 to that in 2006?
Give a very brief answer. 1.03. What is the ratio of the Tax (as % of total tax revenue) of Indonesia in 2002 to that in 2006?
Your response must be concise. 0.99. What is the ratio of the Tax (as % of total tax revenue) of Namibia in 2002 to that in 2006?
Your response must be concise. 1.34. What is the ratio of the Tax (as % of total tax revenue) in United States in 2002 to that in 2006?
Make the answer very short. 0.98. What is the ratio of the Tax (as % of total tax revenue) in Czech Republic in 2002 to that in 2007?
Keep it short and to the point. 1.01. What is the ratio of the Tax (as % of total tax revenue) of Indonesia in 2002 to that in 2007?
Your answer should be very brief. 0.97. What is the ratio of the Tax (as % of total tax revenue) of Namibia in 2002 to that in 2007?
Ensure brevity in your answer.  1.57. What is the ratio of the Tax (as % of total tax revenue) of United States in 2002 to that in 2007?
Provide a short and direct response. 0.97. What is the ratio of the Tax (as % of total tax revenue) of Czech Republic in 2003 to that in 2004?
Offer a terse response. 1.02. What is the ratio of the Tax (as % of total tax revenue) of Indonesia in 2003 to that in 2004?
Provide a succinct answer. 1.1. What is the ratio of the Tax (as % of total tax revenue) of Namibia in 2003 to that in 2004?
Provide a short and direct response. 1.08. What is the ratio of the Tax (as % of total tax revenue) in Czech Republic in 2003 to that in 2005?
Your response must be concise. 0.99. What is the ratio of the Tax (as % of total tax revenue) of Indonesia in 2003 to that in 2005?
Your answer should be very brief. 0.67. What is the ratio of the Tax (as % of total tax revenue) of Namibia in 2003 to that in 2005?
Give a very brief answer. 1.09. What is the ratio of the Tax (as % of total tax revenue) of United States in 2003 to that in 2005?
Keep it short and to the point. 0.98. What is the ratio of the Tax (as % of total tax revenue) of Czech Republic in 2003 to that in 2006?
Keep it short and to the point. 1.05. What is the ratio of the Tax (as % of total tax revenue) of Namibia in 2003 to that in 2006?
Offer a terse response. 1.16. What is the ratio of the Tax (as % of total tax revenue) in United States in 2003 to that in 2006?
Your answer should be compact. 0.98. What is the ratio of the Tax (as % of total tax revenue) of Czech Republic in 2003 to that in 2007?
Ensure brevity in your answer.  1.03. What is the ratio of the Tax (as % of total tax revenue) of Indonesia in 2003 to that in 2007?
Ensure brevity in your answer.  0.95. What is the ratio of the Tax (as % of total tax revenue) of Namibia in 2003 to that in 2007?
Give a very brief answer. 1.37. What is the ratio of the Tax (as % of total tax revenue) of United States in 2003 to that in 2007?
Your answer should be very brief. 0.97. What is the ratio of the Tax (as % of total tax revenue) in Czech Republic in 2004 to that in 2005?
Your answer should be very brief. 0.97. What is the ratio of the Tax (as % of total tax revenue) in Indonesia in 2004 to that in 2005?
Your response must be concise. 0.61. What is the ratio of the Tax (as % of total tax revenue) of Namibia in 2004 to that in 2005?
Give a very brief answer. 1.01. What is the ratio of the Tax (as % of total tax revenue) of United States in 2004 to that in 2005?
Ensure brevity in your answer.  0.99. What is the ratio of the Tax (as % of total tax revenue) of Czech Republic in 2004 to that in 2006?
Offer a terse response. 1.03. What is the ratio of the Tax (as % of total tax revenue) of Indonesia in 2004 to that in 2006?
Your answer should be compact. 0.88. What is the ratio of the Tax (as % of total tax revenue) of Namibia in 2004 to that in 2006?
Provide a short and direct response. 1.08. What is the ratio of the Tax (as % of total tax revenue) in United States in 2004 to that in 2006?
Your answer should be compact. 0.98. What is the ratio of the Tax (as % of total tax revenue) in Czech Republic in 2004 to that in 2007?
Provide a succinct answer. 1.01. What is the ratio of the Tax (as % of total tax revenue) of Indonesia in 2004 to that in 2007?
Give a very brief answer. 0.86. What is the ratio of the Tax (as % of total tax revenue) in Namibia in 2004 to that in 2007?
Your answer should be compact. 1.27. What is the ratio of the Tax (as % of total tax revenue) of United States in 2004 to that in 2007?
Make the answer very short. 0.97. What is the ratio of the Tax (as % of total tax revenue) of Czech Republic in 2005 to that in 2006?
Your response must be concise. 1.06. What is the ratio of the Tax (as % of total tax revenue) in Indonesia in 2005 to that in 2006?
Provide a succinct answer. 1.43. What is the ratio of the Tax (as % of total tax revenue) in Namibia in 2005 to that in 2006?
Offer a very short reply. 1.07. What is the ratio of the Tax (as % of total tax revenue) in United States in 2005 to that in 2006?
Provide a short and direct response. 0.99. What is the ratio of the Tax (as % of total tax revenue) in Czech Republic in 2005 to that in 2007?
Provide a short and direct response. 1.04. What is the ratio of the Tax (as % of total tax revenue) in Indonesia in 2005 to that in 2007?
Offer a very short reply. 1.41. What is the ratio of the Tax (as % of total tax revenue) in Namibia in 2005 to that in 2007?
Provide a short and direct response. 1.25. What is the ratio of the Tax (as % of total tax revenue) of United States in 2005 to that in 2007?
Offer a terse response. 0.98. What is the ratio of the Tax (as % of total tax revenue) in Czech Republic in 2006 to that in 2007?
Offer a terse response. 0.98. What is the ratio of the Tax (as % of total tax revenue) of Indonesia in 2006 to that in 2007?
Keep it short and to the point. 0.98. What is the ratio of the Tax (as % of total tax revenue) of Namibia in 2006 to that in 2007?
Keep it short and to the point. 1.18. What is the difference between the highest and the second highest Tax (as % of total tax revenue) of Czech Republic?
Give a very brief answer. 0.46. What is the difference between the highest and the second highest Tax (as % of total tax revenue) of Indonesia?
Keep it short and to the point. 19.79. What is the difference between the highest and the second highest Tax (as % of total tax revenue) of Namibia?
Give a very brief answer. 6.42. What is the difference between the highest and the second highest Tax (as % of total tax revenue) in United States?
Offer a terse response. 0.72. What is the difference between the highest and the lowest Tax (as % of total tax revenue) of Czech Republic?
Provide a succinct answer. 2.4. What is the difference between the highest and the lowest Tax (as % of total tax revenue) of Indonesia?
Provide a succinct answer. 26.36. What is the difference between the highest and the lowest Tax (as % of total tax revenue) in Namibia?
Provide a succinct answer. 17.62. What is the difference between the highest and the lowest Tax (as % of total tax revenue) in United States?
Your answer should be very brief. 2.97. 